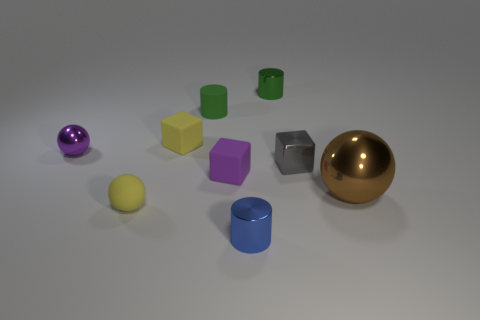What size is the other metal thing that is the same shape as the tiny purple metal thing?
Ensure brevity in your answer.  Large. Are the small block that is to the right of the small blue thing and the big brown thing made of the same material?
Your answer should be very brief. Yes. Is the number of matte objects to the right of the tiny gray thing the same as the number of large cyan cubes?
Keep it short and to the point. Yes. How big is the brown shiny object?
Provide a short and direct response. Large. There is a tiny block that is the same color as the tiny metal ball; what is it made of?
Your answer should be very brief. Rubber. What number of metal things are the same color as the small rubber sphere?
Give a very brief answer. 0. Is the purple rubber thing the same size as the blue thing?
Your answer should be compact. Yes. There is a green metallic cylinder that is to the left of the sphere that is right of the tiny metal cube; what is its size?
Offer a very short reply. Small. There is a matte cylinder; is its color the same as the tiny metal cylinder that is behind the tiny gray object?
Ensure brevity in your answer.  Yes. Is there a metal block of the same size as the yellow ball?
Provide a short and direct response. Yes. 